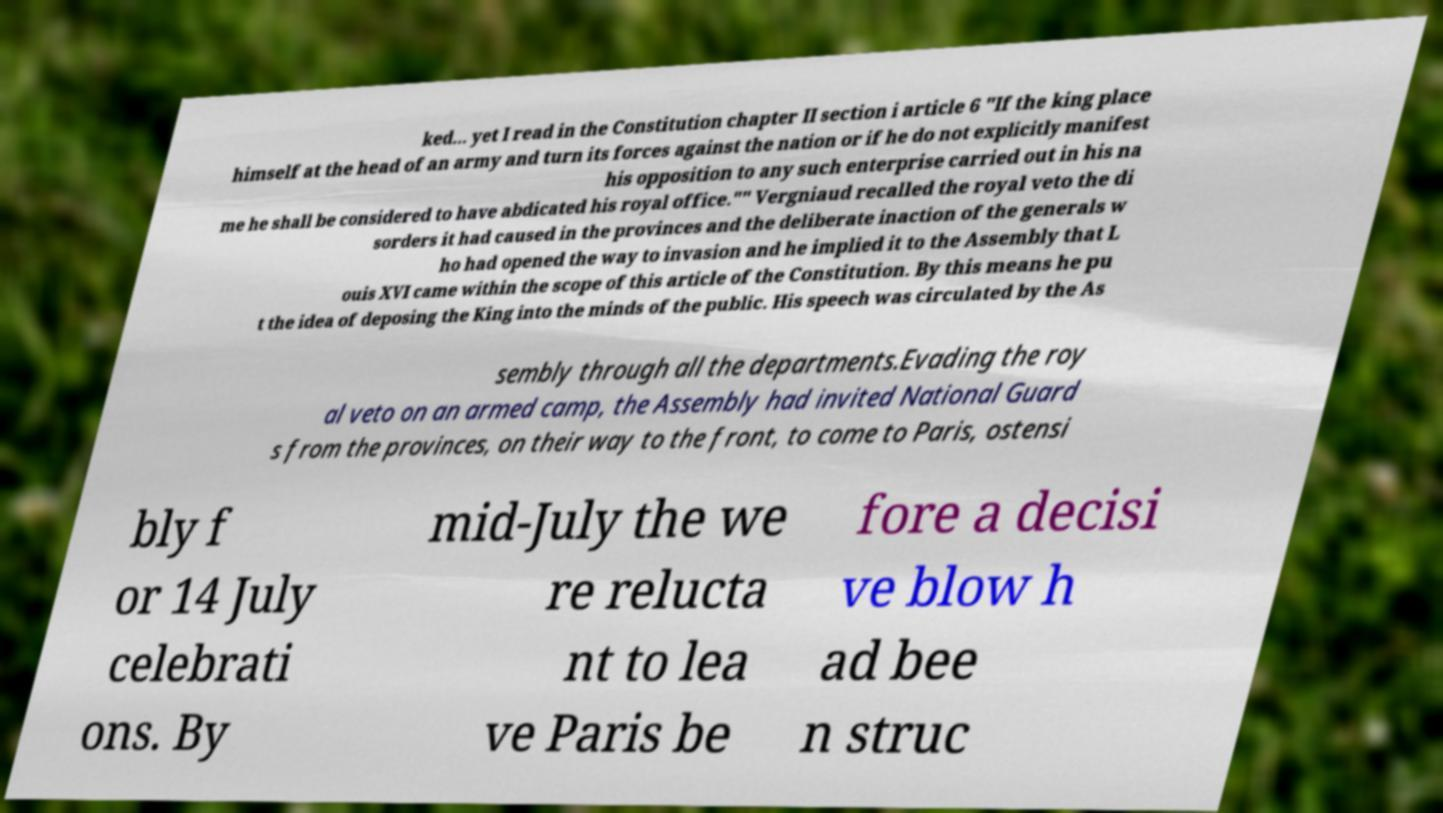I need the written content from this picture converted into text. Can you do that? ked... yet I read in the Constitution chapter II section i article 6 "If the king place himself at the head of an army and turn its forces against the nation or if he do not explicitly manifest his opposition to any such enterprise carried out in his na me he shall be considered to have abdicated his royal office."" Vergniaud recalled the royal veto the di sorders it had caused in the provinces and the deliberate inaction of the generals w ho had opened the way to invasion and he implied it to the Assembly that L ouis XVI came within the scope of this article of the Constitution. By this means he pu t the idea of deposing the King into the minds of the public. His speech was circulated by the As sembly through all the departments.Evading the roy al veto on an armed camp, the Assembly had invited National Guard s from the provinces, on their way to the front, to come to Paris, ostensi bly f or 14 July celebrati ons. By mid-July the we re relucta nt to lea ve Paris be fore a decisi ve blow h ad bee n struc 